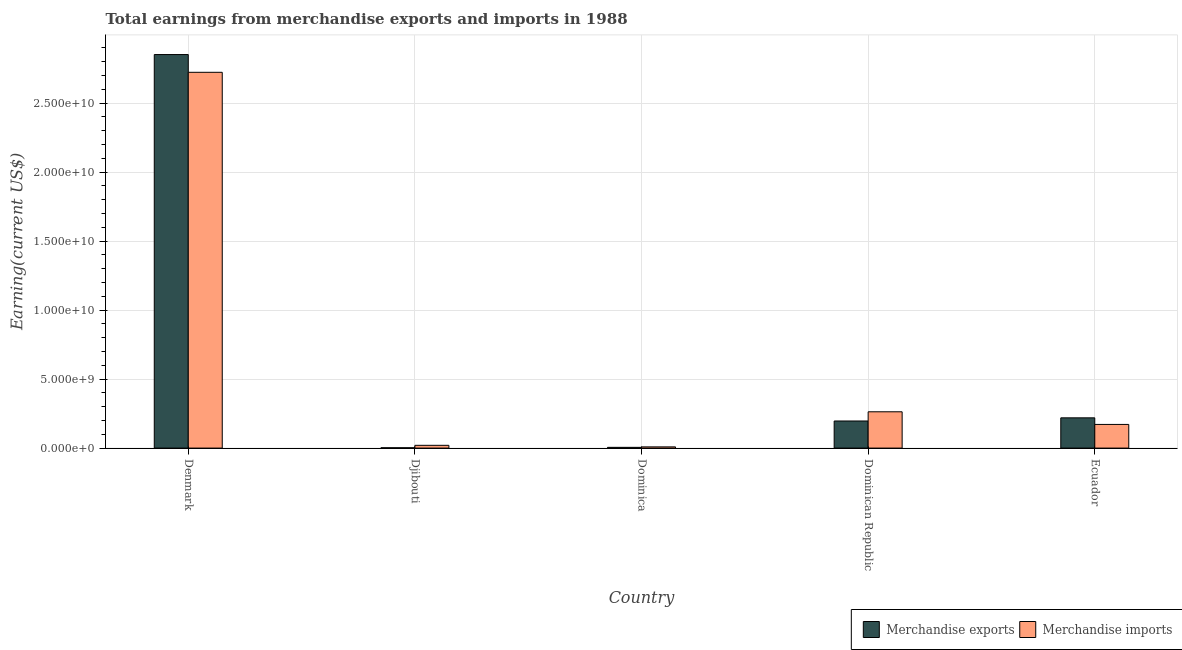How many different coloured bars are there?
Your answer should be compact. 2. How many groups of bars are there?
Your answer should be compact. 5. Are the number of bars on each tick of the X-axis equal?
Make the answer very short. Yes. How many bars are there on the 3rd tick from the left?
Give a very brief answer. 2. How many bars are there on the 1st tick from the right?
Provide a succinct answer. 2. What is the label of the 3rd group of bars from the left?
Give a very brief answer. Dominica. In how many cases, is the number of bars for a given country not equal to the number of legend labels?
Your response must be concise. 0. What is the earnings from merchandise imports in Dominica?
Make the answer very short. 8.80e+07. Across all countries, what is the maximum earnings from merchandise imports?
Keep it short and to the point. 2.72e+1. Across all countries, what is the minimum earnings from merchandise exports?
Ensure brevity in your answer.  2.30e+07. In which country was the earnings from merchandise imports maximum?
Your answer should be very brief. Denmark. In which country was the earnings from merchandise imports minimum?
Give a very brief answer. Dominica. What is the total earnings from merchandise imports in the graph?
Your answer should be compact. 3.19e+1. What is the difference between the earnings from merchandise exports in Djibouti and that in Ecuador?
Offer a very short reply. -2.17e+09. What is the difference between the earnings from merchandise imports in Ecuador and the earnings from merchandise exports in Djibouti?
Provide a succinct answer. 1.69e+09. What is the average earnings from merchandise exports per country?
Offer a terse response. 6.55e+09. What is the difference between the earnings from merchandise exports and earnings from merchandise imports in Ecuador?
Keep it short and to the point. 4.78e+08. What is the ratio of the earnings from merchandise imports in Dominican Republic to that in Ecuador?
Ensure brevity in your answer.  1.53. Is the earnings from merchandise imports in Denmark less than that in Ecuador?
Make the answer very short. No. What is the difference between the highest and the second highest earnings from merchandise exports?
Offer a very short reply. 2.63e+1. What is the difference between the highest and the lowest earnings from merchandise exports?
Ensure brevity in your answer.  2.85e+1. In how many countries, is the earnings from merchandise exports greater than the average earnings from merchandise exports taken over all countries?
Ensure brevity in your answer.  1. What does the 2nd bar from the left in Ecuador represents?
Your answer should be very brief. Merchandise imports. What does the 2nd bar from the right in Djibouti represents?
Ensure brevity in your answer.  Merchandise exports. How many countries are there in the graph?
Ensure brevity in your answer.  5. What is the difference between two consecutive major ticks on the Y-axis?
Offer a very short reply. 5.00e+09. Are the values on the major ticks of Y-axis written in scientific E-notation?
Give a very brief answer. Yes. Does the graph contain grids?
Provide a short and direct response. Yes. How are the legend labels stacked?
Make the answer very short. Horizontal. What is the title of the graph?
Provide a succinct answer. Total earnings from merchandise exports and imports in 1988. What is the label or title of the X-axis?
Ensure brevity in your answer.  Country. What is the label or title of the Y-axis?
Offer a terse response. Earning(current US$). What is the Earning(current US$) of Merchandise exports in Denmark?
Your answer should be compact. 2.85e+1. What is the Earning(current US$) in Merchandise imports in Denmark?
Provide a short and direct response. 2.72e+1. What is the Earning(current US$) of Merchandise exports in Djibouti?
Your answer should be very brief. 2.30e+07. What is the Earning(current US$) in Merchandise imports in Djibouti?
Provide a short and direct response. 2.01e+08. What is the Earning(current US$) in Merchandise exports in Dominica?
Give a very brief answer. 5.40e+07. What is the Earning(current US$) in Merchandise imports in Dominica?
Offer a very short reply. 8.80e+07. What is the Earning(current US$) of Merchandise exports in Dominican Republic?
Your answer should be compact. 1.96e+09. What is the Earning(current US$) of Merchandise imports in Dominican Republic?
Your answer should be very brief. 2.63e+09. What is the Earning(current US$) in Merchandise exports in Ecuador?
Your response must be concise. 2.19e+09. What is the Earning(current US$) in Merchandise imports in Ecuador?
Provide a short and direct response. 1.71e+09. Across all countries, what is the maximum Earning(current US$) of Merchandise exports?
Your answer should be very brief. 2.85e+1. Across all countries, what is the maximum Earning(current US$) in Merchandise imports?
Your response must be concise. 2.72e+1. Across all countries, what is the minimum Earning(current US$) of Merchandise exports?
Make the answer very short. 2.30e+07. Across all countries, what is the minimum Earning(current US$) of Merchandise imports?
Provide a succinct answer. 8.80e+07. What is the total Earning(current US$) of Merchandise exports in the graph?
Your answer should be compact. 3.27e+1. What is the total Earning(current US$) of Merchandise imports in the graph?
Offer a very short reply. 3.19e+1. What is the difference between the Earning(current US$) in Merchandise exports in Denmark and that in Djibouti?
Provide a succinct answer. 2.85e+1. What is the difference between the Earning(current US$) in Merchandise imports in Denmark and that in Djibouti?
Ensure brevity in your answer.  2.70e+1. What is the difference between the Earning(current US$) in Merchandise exports in Denmark and that in Dominica?
Offer a very short reply. 2.85e+1. What is the difference between the Earning(current US$) in Merchandise imports in Denmark and that in Dominica?
Offer a terse response. 2.71e+1. What is the difference between the Earning(current US$) in Merchandise exports in Denmark and that in Dominican Republic?
Your response must be concise. 2.66e+1. What is the difference between the Earning(current US$) of Merchandise imports in Denmark and that in Dominican Republic?
Provide a succinct answer. 2.46e+1. What is the difference between the Earning(current US$) in Merchandise exports in Denmark and that in Ecuador?
Keep it short and to the point. 2.63e+1. What is the difference between the Earning(current US$) in Merchandise imports in Denmark and that in Ecuador?
Your answer should be compact. 2.55e+1. What is the difference between the Earning(current US$) of Merchandise exports in Djibouti and that in Dominica?
Offer a very short reply. -3.10e+07. What is the difference between the Earning(current US$) in Merchandise imports in Djibouti and that in Dominica?
Provide a succinct answer. 1.13e+08. What is the difference between the Earning(current US$) in Merchandise exports in Djibouti and that in Dominican Republic?
Ensure brevity in your answer.  -1.94e+09. What is the difference between the Earning(current US$) of Merchandise imports in Djibouti and that in Dominican Republic?
Offer a very short reply. -2.43e+09. What is the difference between the Earning(current US$) of Merchandise exports in Djibouti and that in Ecuador?
Make the answer very short. -2.17e+09. What is the difference between the Earning(current US$) of Merchandise imports in Djibouti and that in Ecuador?
Provide a short and direct response. -1.51e+09. What is the difference between the Earning(current US$) in Merchandise exports in Dominica and that in Dominican Republic?
Make the answer very short. -1.91e+09. What is the difference between the Earning(current US$) of Merchandise imports in Dominica and that in Dominican Republic?
Provide a short and direct response. -2.54e+09. What is the difference between the Earning(current US$) of Merchandise exports in Dominica and that in Ecuador?
Your answer should be compact. -2.14e+09. What is the difference between the Earning(current US$) of Merchandise imports in Dominica and that in Ecuador?
Keep it short and to the point. -1.63e+09. What is the difference between the Earning(current US$) in Merchandise exports in Dominican Republic and that in Ecuador?
Ensure brevity in your answer.  -2.29e+08. What is the difference between the Earning(current US$) of Merchandise imports in Dominican Republic and that in Ecuador?
Ensure brevity in your answer.  9.16e+08. What is the difference between the Earning(current US$) of Merchandise exports in Denmark and the Earning(current US$) of Merchandise imports in Djibouti?
Ensure brevity in your answer.  2.83e+1. What is the difference between the Earning(current US$) of Merchandise exports in Denmark and the Earning(current US$) of Merchandise imports in Dominica?
Your answer should be very brief. 2.84e+1. What is the difference between the Earning(current US$) in Merchandise exports in Denmark and the Earning(current US$) in Merchandise imports in Dominican Republic?
Your answer should be compact. 2.59e+1. What is the difference between the Earning(current US$) of Merchandise exports in Denmark and the Earning(current US$) of Merchandise imports in Ecuador?
Offer a very short reply. 2.68e+1. What is the difference between the Earning(current US$) of Merchandise exports in Djibouti and the Earning(current US$) of Merchandise imports in Dominica?
Provide a succinct answer. -6.50e+07. What is the difference between the Earning(current US$) in Merchandise exports in Djibouti and the Earning(current US$) in Merchandise imports in Dominican Republic?
Your response must be concise. -2.61e+09. What is the difference between the Earning(current US$) of Merchandise exports in Djibouti and the Earning(current US$) of Merchandise imports in Ecuador?
Offer a very short reply. -1.69e+09. What is the difference between the Earning(current US$) in Merchandise exports in Dominica and the Earning(current US$) in Merchandise imports in Dominican Republic?
Your answer should be compact. -2.58e+09. What is the difference between the Earning(current US$) of Merchandise exports in Dominica and the Earning(current US$) of Merchandise imports in Ecuador?
Provide a short and direct response. -1.66e+09. What is the difference between the Earning(current US$) in Merchandise exports in Dominican Republic and the Earning(current US$) in Merchandise imports in Ecuador?
Your answer should be very brief. 2.49e+08. What is the average Earning(current US$) in Merchandise exports per country?
Keep it short and to the point. 6.55e+09. What is the average Earning(current US$) in Merchandise imports per country?
Your answer should be compact. 6.37e+09. What is the difference between the Earning(current US$) of Merchandise exports and Earning(current US$) of Merchandise imports in Denmark?
Your response must be concise. 1.29e+09. What is the difference between the Earning(current US$) of Merchandise exports and Earning(current US$) of Merchandise imports in Djibouti?
Make the answer very short. -1.78e+08. What is the difference between the Earning(current US$) in Merchandise exports and Earning(current US$) in Merchandise imports in Dominica?
Give a very brief answer. -3.40e+07. What is the difference between the Earning(current US$) of Merchandise exports and Earning(current US$) of Merchandise imports in Dominican Republic?
Offer a terse response. -6.67e+08. What is the difference between the Earning(current US$) in Merchandise exports and Earning(current US$) in Merchandise imports in Ecuador?
Give a very brief answer. 4.78e+08. What is the ratio of the Earning(current US$) of Merchandise exports in Denmark to that in Djibouti?
Keep it short and to the point. 1239.74. What is the ratio of the Earning(current US$) of Merchandise imports in Denmark to that in Djibouti?
Provide a short and direct response. 135.46. What is the ratio of the Earning(current US$) in Merchandise exports in Denmark to that in Dominica?
Offer a terse response. 528.04. What is the ratio of the Earning(current US$) of Merchandise imports in Denmark to that in Dominica?
Make the answer very short. 309.41. What is the ratio of the Earning(current US$) of Merchandise exports in Denmark to that in Dominican Republic?
Your answer should be compact. 14.53. What is the ratio of the Earning(current US$) in Merchandise imports in Denmark to that in Dominican Republic?
Give a very brief answer. 10.35. What is the ratio of the Earning(current US$) of Merchandise exports in Denmark to that in Ecuador?
Provide a short and direct response. 13.01. What is the ratio of the Earning(current US$) in Merchandise imports in Denmark to that in Ecuador?
Offer a terse response. 15.89. What is the ratio of the Earning(current US$) of Merchandise exports in Djibouti to that in Dominica?
Offer a very short reply. 0.43. What is the ratio of the Earning(current US$) in Merchandise imports in Djibouti to that in Dominica?
Offer a very short reply. 2.28. What is the ratio of the Earning(current US$) of Merchandise exports in Djibouti to that in Dominican Republic?
Offer a very short reply. 0.01. What is the ratio of the Earning(current US$) in Merchandise imports in Djibouti to that in Dominican Republic?
Offer a terse response. 0.08. What is the ratio of the Earning(current US$) in Merchandise exports in Djibouti to that in Ecuador?
Offer a very short reply. 0.01. What is the ratio of the Earning(current US$) of Merchandise imports in Djibouti to that in Ecuador?
Give a very brief answer. 0.12. What is the ratio of the Earning(current US$) in Merchandise exports in Dominica to that in Dominican Republic?
Your answer should be compact. 0.03. What is the ratio of the Earning(current US$) of Merchandise imports in Dominica to that in Dominican Republic?
Offer a very short reply. 0.03. What is the ratio of the Earning(current US$) in Merchandise exports in Dominica to that in Ecuador?
Provide a succinct answer. 0.02. What is the ratio of the Earning(current US$) in Merchandise imports in Dominica to that in Ecuador?
Offer a terse response. 0.05. What is the ratio of the Earning(current US$) in Merchandise exports in Dominican Republic to that in Ecuador?
Keep it short and to the point. 0.9. What is the ratio of the Earning(current US$) in Merchandise imports in Dominican Republic to that in Ecuador?
Your answer should be compact. 1.53. What is the difference between the highest and the second highest Earning(current US$) in Merchandise exports?
Ensure brevity in your answer.  2.63e+1. What is the difference between the highest and the second highest Earning(current US$) in Merchandise imports?
Your answer should be compact. 2.46e+1. What is the difference between the highest and the lowest Earning(current US$) of Merchandise exports?
Provide a succinct answer. 2.85e+1. What is the difference between the highest and the lowest Earning(current US$) of Merchandise imports?
Your response must be concise. 2.71e+1. 